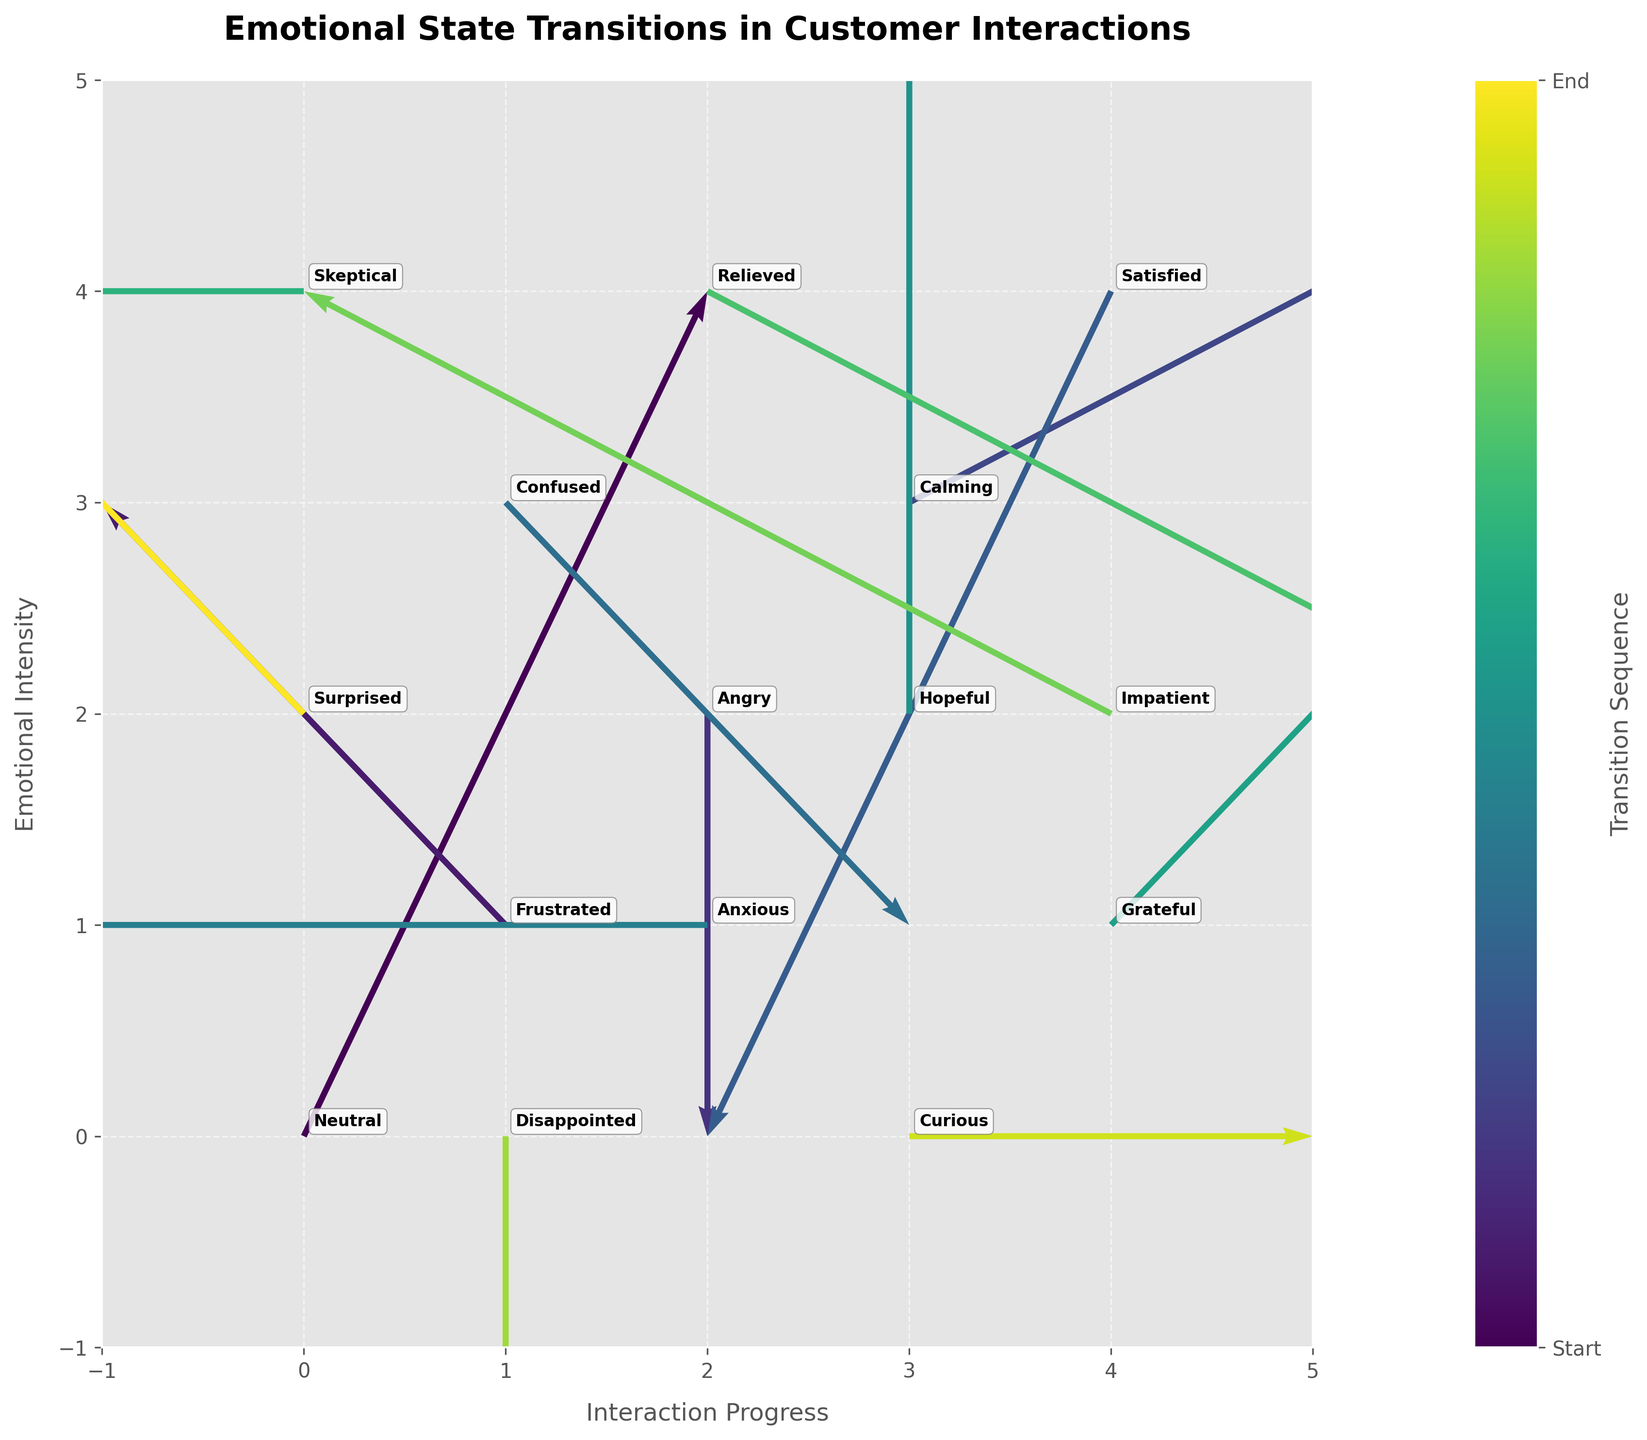What is the title of the plot? The title of the plot is often displayed at the top of the figure. Upon looking at the figure, we can read it directly.
Answer: Emotional State Transitions in Customer Interactions How many emotional states are represented in the figure? By counting the unique labels of emotions around the data points in the plot, we can determine the number of emotional states present.
Answer: 15 Which emotional state shows the largest change in the direction of increasing 'y' (emotional intensity)? We observe the arrows pointing in different directions. The arrow associated with 'Hopeful' at (3,2) has the largest positive 'v' component, showing the largest upward change in emotional intensity.
Answer: Hopeful Which arrows show a change in emotional intensity without moving horizontally (no change in 'x')? By identifying arrows with 'u' components equal to 0, we can find these arrows. 'Angry' at (2,2), and 'Hopeful' at (3,2) have changes in 'y' only.
Answer: Angry, Hopeful Which emotional state starts at the highest interaction progress? The x-axis represents interaction progress. The state starting at the highest x value (4) is 'Satisfied'.
Answer: Satisfied What is the direction of change for the emotional state 'Curious'? Directing attention to 'Curious' at (3,0), we can see the associated arrow shows an increase along the x-axis without changing in y.
Answer: Increase in x Which emotional state shows a transition that decreases both interaction progress and emotional intensity at the same time? By looking for negative components in both 'u' and 'v' of the arrows, the 'Satisfied' state at (4,4) fits this criteria.
Answer: Satisfied How many emotional states show a transition with no change in emotional intensity? Identifying arrows with 'v' component equal to 0 leads us to find 'Anxious' at (2,1), 'Curious' at (3,0) and 'Skeptical' at (0,4).
Answer: 3 What is the general trend for the flow of emotional states from 'Frustrated' at (1,1) in terms of horizontal and vertical changes? The arrow starting at 'Frustrated' at (1,1) moves to the left (negative 'u') and upwards (positive 'v'), indicating a decrease in 'x' and an increase in 'y'.
Answer: Decrease in x, Increase in y Comparing 'Confused' at (1,3) and 'Skeptical' at (0,4), which one leads to a decrease in emotional intensity? Observing the arrows starting from these states, the arrow for 'Confused' has a downward direction (negative 'v'), indicating a decrease in intensity, while 'Skeptical' has no change in 'y'.
Answer: Confused 